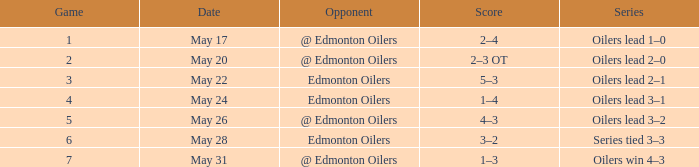Competitor against edmonton oilers, and a collection of 3 games belongs to which series? Oilers lead 2–1. 